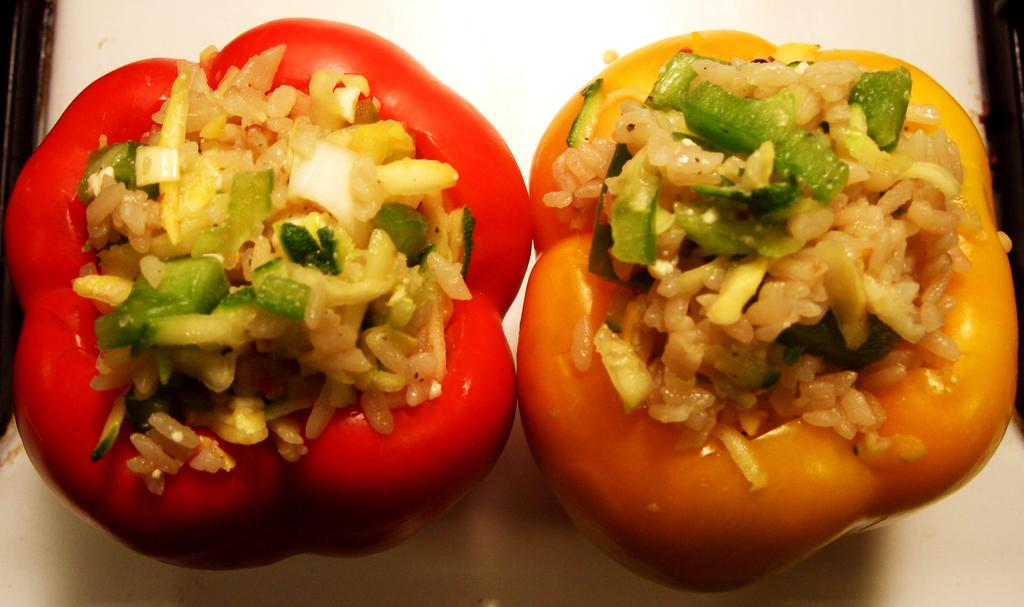What type of capsicums are present in the image? There is a yellow capsicum and a red capsicum in the image. What is inside the capsicums? The capsicums contain rice and vegetable stuffing. What type of fan is visible in the image? There is no fan present in the image; it only features capsicums with rice and vegetable stuffing. 